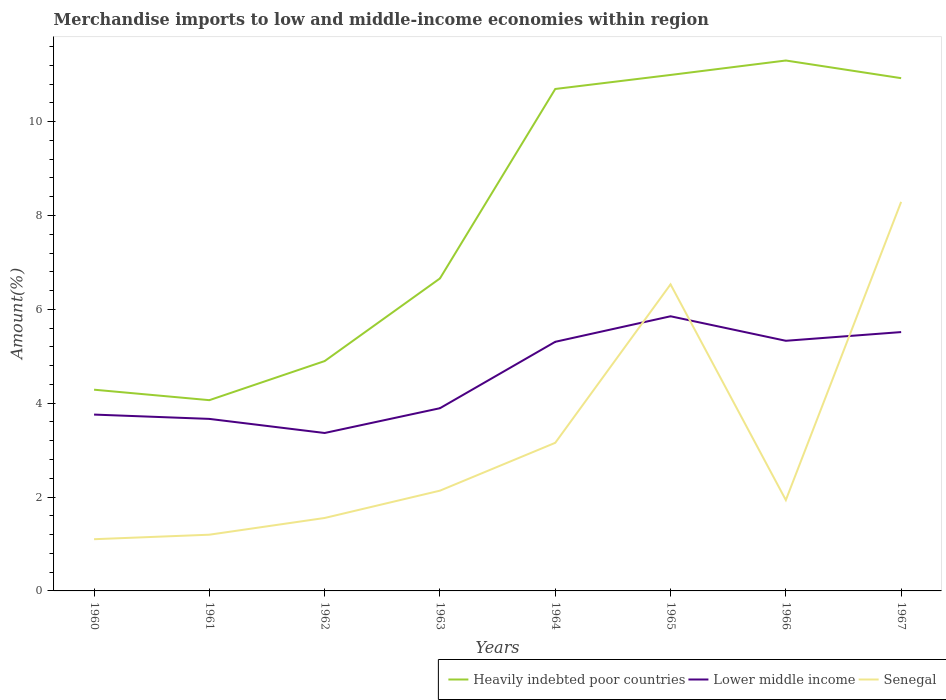How many different coloured lines are there?
Your answer should be very brief. 3. Is the number of lines equal to the number of legend labels?
Your response must be concise. Yes. Across all years, what is the maximum percentage of amount earned from merchandise imports in Heavily indebted poor countries?
Ensure brevity in your answer.  4.06. In which year was the percentage of amount earned from merchandise imports in Heavily indebted poor countries maximum?
Provide a short and direct response. 1961. What is the total percentage of amount earned from merchandise imports in Lower middle income in the graph?
Your answer should be compact. -1.94. What is the difference between the highest and the second highest percentage of amount earned from merchandise imports in Heavily indebted poor countries?
Your response must be concise. 7.24. Is the percentage of amount earned from merchandise imports in Lower middle income strictly greater than the percentage of amount earned from merchandise imports in Senegal over the years?
Offer a very short reply. No. How many lines are there?
Your response must be concise. 3. How many years are there in the graph?
Provide a succinct answer. 8. Does the graph contain grids?
Ensure brevity in your answer.  No. How are the legend labels stacked?
Make the answer very short. Horizontal. What is the title of the graph?
Your answer should be very brief. Merchandise imports to low and middle-income economies within region. What is the label or title of the X-axis?
Your answer should be very brief. Years. What is the label or title of the Y-axis?
Offer a very short reply. Amount(%). What is the Amount(%) in Heavily indebted poor countries in 1960?
Provide a short and direct response. 4.29. What is the Amount(%) in Lower middle income in 1960?
Your response must be concise. 3.76. What is the Amount(%) in Senegal in 1960?
Offer a very short reply. 1.1. What is the Amount(%) in Heavily indebted poor countries in 1961?
Offer a very short reply. 4.06. What is the Amount(%) of Lower middle income in 1961?
Offer a very short reply. 3.67. What is the Amount(%) of Senegal in 1961?
Your response must be concise. 1.2. What is the Amount(%) in Heavily indebted poor countries in 1962?
Give a very brief answer. 4.9. What is the Amount(%) of Lower middle income in 1962?
Your response must be concise. 3.37. What is the Amount(%) of Senegal in 1962?
Keep it short and to the point. 1.55. What is the Amount(%) in Heavily indebted poor countries in 1963?
Ensure brevity in your answer.  6.66. What is the Amount(%) of Lower middle income in 1963?
Provide a succinct answer. 3.89. What is the Amount(%) of Senegal in 1963?
Provide a succinct answer. 2.14. What is the Amount(%) in Heavily indebted poor countries in 1964?
Provide a short and direct response. 10.7. What is the Amount(%) in Lower middle income in 1964?
Ensure brevity in your answer.  5.31. What is the Amount(%) in Senegal in 1964?
Offer a very short reply. 3.16. What is the Amount(%) in Heavily indebted poor countries in 1965?
Make the answer very short. 10.99. What is the Amount(%) of Lower middle income in 1965?
Provide a succinct answer. 5.85. What is the Amount(%) of Senegal in 1965?
Ensure brevity in your answer.  6.53. What is the Amount(%) of Heavily indebted poor countries in 1966?
Give a very brief answer. 11.3. What is the Amount(%) of Lower middle income in 1966?
Make the answer very short. 5.33. What is the Amount(%) in Senegal in 1966?
Your answer should be compact. 1.94. What is the Amount(%) in Heavily indebted poor countries in 1967?
Provide a succinct answer. 10.93. What is the Amount(%) in Lower middle income in 1967?
Provide a short and direct response. 5.52. What is the Amount(%) of Senegal in 1967?
Provide a short and direct response. 8.29. Across all years, what is the maximum Amount(%) in Heavily indebted poor countries?
Ensure brevity in your answer.  11.3. Across all years, what is the maximum Amount(%) in Lower middle income?
Offer a terse response. 5.85. Across all years, what is the maximum Amount(%) of Senegal?
Offer a terse response. 8.29. Across all years, what is the minimum Amount(%) in Heavily indebted poor countries?
Your response must be concise. 4.06. Across all years, what is the minimum Amount(%) in Lower middle income?
Offer a terse response. 3.37. Across all years, what is the minimum Amount(%) of Senegal?
Your answer should be compact. 1.1. What is the total Amount(%) in Heavily indebted poor countries in the graph?
Offer a terse response. 63.83. What is the total Amount(%) of Lower middle income in the graph?
Your answer should be compact. 36.69. What is the total Amount(%) of Senegal in the graph?
Your response must be concise. 25.9. What is the difference between the Amount(%) of Heavily indebted poor countries in 1960 and that in 1961?
Your answer should be very brief. 0.22. What is the difference between the Amount(%) in Lower middle income in 1960 and that in 1961?
Offer a very short reply. 0.09. What is the difference between the Amount(%) of Senegal in 1960 and that in 1961?
Provide a short and direct response. -0.1. What is the difference between the Amount(%) of Heavily indebted poor countries in 1960 and that in 1962?
Offer a very short reply. -0.61. What is the difference between the Amount(%) in Lower middle income in 1960 and that in 1962?
Keep it short and to the point. 0.39. What is the difference between the Amount(%) of Senegal in 1960 and that in 1962?
Ensure brevity in your answer.  -0.45. What is the difference between the Amount(%) in Heavily indebted poor countries in 1960 and that in 1963?
Offer a terse response. -2.37. What is the difference between the Amount(%) of Lower middle income in 1960 and that in 1963?
Your answer should be very brief. -0.14. What is the difference between the Amount(%) in Senegal in 1960 and that in 1963?
Keep it short and to the point. -1.03. What is the difference between the Amount(%) in Heavily indebted poor countries in 1960 and that in 1964?
Make the answer very short. -6.41. What is the difference between the Amount(%) in Lower middle income in 1960 and that in 1964?
Provide a short and direct response. -1.55. What is the difference between the Amount(%) of Senegal in 1960 and that in 1964?
Offer a very short reply. -2.05. What is the difference between the Amount(%) in Heavily indebted poor countries in 1960 and that in 1965?
Your answer should be compact. -6.71. What is the difference between the Amount(%) of Lower middle income in 1960 and that in 1965?
Make the answer very short. -2.09. What is the difference between the Amount(%) in Senegal in 1960 and that in 1965?
Your answer should be compact. -5.43. What is the difference between the Amount(%) in Heavily indebted poor countries in 1960 and that in 1966?
Your answer should be compact. -7.01. What is the difference between the Amount(%) of Lower middle income in 1960 and that in 1966?
Keep it short and to the point. -1.57. What is the difference between the Amount(%) of Senegal in 1960 and that in 1966?
Your response must be concise. -0.83. What is the difference between the Amount(%) of Heavily indebted poor countries in 1960 and that in 1967?
Provide a short and direct response. -6.64. What is the difference between the Amount(%) in Lower middle income in 1960 and that in 1967?
Your answer should be very brief. -1.76. What is the difference between the Amount(%) of Senegal in 1960 and that in 1967?
Provide a short and direct response. -7.19. What is the difference between the Amount(%) of Heavily indebted poor countries in 1961 and that in 1962?
Keep it short and to the point. -0.83. What is the difference between the Amount(%) in Lower middle income in 1961 and that in 1962?
Offer a very short reply. 0.3. What is the difference between the Amount(%) in Senegal in 1961 and that in 1962?
Your response must be concise. -0.36. What is the difference between the Amount(%) in Heavily indebted poor countries in 1961 and that in 1963?
Provide a short and direct response. -2.59. What is the difference between the Amount(%) of Lower middle income in 1961 and that in 1963?
Offer a terse response. -0.23. What is the difference between the Amount(%) in Senegal in 1961 and that in 1963?
Your answer should be compact. -0.94. What is the difference between the Amount(%) in Heavily indebted poor countries in 1961 and that in 1964?
Keep it short and to the point. -6.63. What is the difference between the Amount(%) in Lower middle income in 1961 and that in 1964?
Ensure brevity in your answer.  -1.64. What is the difference between the Amount(%) in Senegal in 1961 and that in 1964?
Ensure brevity in your answer.  -1.96. What is the difference between the Amount(%) of Heavily indebted poor countries in 1961 and that in 1965?
Make the answer very short. -6.93. What is the difference between the Amount(%) of Lower middle income in 1961 and that in 1965?
Your answer should be compact. -2.19. What is the difference between the Amount(%) of Senegal in 1961 and that in 1965?
Your answer should be very brief. -5.33. What is the difference between the Amount(%) of Heavily indebted poor countries in 1961 and that in 1966?
Your answer should be compact. -7.24. What is the difference between the Amount(%) in Lower middle income in 1961 and that in 1966?
Make the answer very short. -1.66. What is the difference between the Amount(%) of Senegal in 1961 and that in 1966?
Give a very brief answer. -0.74. What is the difference between the Amount(%) of Heavily indebted poor countries in 1961 and that in 1967?
Your answer should be very brief. -6.86. What is the difference between the Amount(%) of Lower middle income in 1961 and that in 1967?
Provide a short and direct response. -1.85. What is the difference between the Amount(%) of Senegal in 1961 and that in 1967?
Offer a very short reply. -7.09. What is the difference between the Amount(%) of Heavily indebted poor countries in 1962 and that in 1963?
Ensure brevity in your answer.  -1.76. What is the difference between the Amount(%) of Lower middle income in 1962 and that in 1963?
Ensure brevity in your answer.  -0.53. What is the difference between the Amount(%) in Senegal in 1962 and that in 1963?
Give a very brief answer. -0.58. What is the difference between the Amount(%) of Heavily indebted poor countries in 1962 and that in 1964?
Your answer should be very brief. -5.8. What is the difference between the Amount(%) of Lower middle income in 1962 and that in 1964?
Your response must be concise. -1.94. What is the difference between the Amount(%) in Senegal in 1962 and that in 1964?
Provide a succinct answer. -1.6. What is the difference between the Amount(%) of Heavily indebted poor countries in 1962 and that in 1965?
Offer a very short reply. -6.1. What is the difference between the Amount(%) in Lower middle income in 1962 and that in 1965?
Give a very brief answer. -2.49. What is the difference between the Amount(%) in Senegal in 1962 and that in 1965?
Provide a short and direct response. -4.98. What is the difference between the Amount(%) of Heavily indebted poor countries in 1962 and that in 1966?
Keep it short and to the point. -6.4. What is the difference between the Amount(%) in Lower middle income in 1962 and that in 1966?
Your answer should be compact. -1.96. What is the difference between the Amount(%) of Senegal in 1962 and that in 1966?
Give a very brief answer. -0.38. What is the difference between the Amount(%) in Heavily indebted poor countries in 1962 and that in 1967?
Ensure brevity in your answer.  -6.03. What is the difference between the Amount(%) in Lower middle income in 1962 and that in 1967?
Your answer should be very brief. -2.15. What is the difference between the Amount(%) in Senegal in 1962 and that in 1967?
Provide a succinct answer. -6.74. What is the difference between the Amount(%) in Heavily indebted poor countries in 1963 and that in 1964?
Ensure brevity in your answer.  -4.04. What is the difference between the Amount(%) in Lower middle income in 1963 and that in 1964?
Your answer should be compact. -1.41. What is the difference between the Amount(%) in Senegal in 1963 and that in 1964?
Keep it short and to the point. -1.02. What is the difference between the Amount(%) of Heavily indebted poor countries in 1963 and that in 1965?
Your answer should be compact. -4.34. What is the difference between the Amount(%) in Lower middle income in 1963 and that in 1965?
Your response must be concise. -1.96. What is the difference between the Amount(%) of Senegal in 1963 and that in 1965?
Ensure brevity in your answer.  -4.4. What is the difference between the Amount(%) in Heavily indebted poor countries in 1963 and that in 1966?
Keep it short and to the point. -4.64. What is the difference between the Amount(%) in Lower middle income in 1963 and that in 1966?
Provide a succinct answer. -1.44. What is the difference between the Amount(%) in Senegal in 1963 and that in 1966?
Ensure brevity in your answer.  0.2. What is the difference between the Amount(%) in Heavily indebted poor countries in 1963 and that in 1967?
Provide a short and direct response. -4.27. What is the difference between the Amount(%) of Lower middle income in 1963 and that in 1967?
Your answer should be very brief. -1.62. What is the difference between the Amount(%) in Senegal in 1963 and that in 1967?
Ensure brevity in your answer.  -6.15. What is the difference between the Amount(%) in Heavily indebted poor countries in 1964 and that in 1965?
Offer a terse response. -0.3. What is the difference between the Amount(%) of Lower middle income in 1964 and that in 1965?
Provide a short and direct response. -0.54. What is the difference between the Amount(%) of Senegal in 1964 and that in 1965?
Ensure brevity in your answer.  -3.38. What is the difference between the Amount(%) of Heavily indebted poor countries in 1964 and that in 1966?
Your answer should be compact. -0.61. What is the difference between the Amount(%) of Lower middle income in 1964 and that in 1966?
Make the answer very short. -0.02. What is the difference between the Amount(%) of Senegal in 1964 and that in 1966?
Offer a terse response. 1.22. What is the difference between the Amount(%) in Heavily indebted poor countries in 1964 and that in 1967?
Keep it short and to the point. -0.23. What is the difference between the Amount(%) of Lower middle income in 1964 and that in 1967?
Make the answer very short. -0.21. What is the difference between the Amount(%) of Senegal in 1964 and that in 1967?
Give a very brief answer. -5.13. What is the difference between the Amount(%) of Heavily indebted poor countries in 1965 and that in 1966?
Keep it short and to the point. -0.31. What is the difference between the Amount(%) in Lower middle income in 1965 and that in 1966?
Ensure brevity in your answer.  0.52. What is the difference between the Amount(%) of Senegal in 1965 and that in 1966?
Provide a short and direct response. 4.6. What is the difference between the Amount(%) of Heavily indebted poor countries in 1965 and that in 1967?
Give a very brief answer. 0.07. What is the difference between the Amount(%) of Lower middle income in 1965 and that in 1967?
Make the answer very short. 0.34. What is the difference between the Amount(%) in Senegal in 1965 and that in 1967?
Give a very brief answer. -1.76. What is the difference between the Amount(%) of Heavily indebted poor countries in 1966 and that in 1967?
Offer a very short reply. 0.38. What is the difference between the Amount(%) in Lower middle income in 1966 and that in 1967?
Offer a very short reply. -0.19. What is the difference between the Amount(%) of Senegal in 1966 and that in 1967?
Offer a very short reply. -6.35. What is the difference between the Amount(%) in Heavily indebted poor countries in 1960 and the Amount(%) in Lower middle income in 1961?
Your answer should be very brief. 0.62. What is the difference between the Amount(%) of Heavily indebted poor countries in 1960 and the Amount(%) of Senegal in 1961?
Offer a very short reply. 3.09. What is the difference between the Amount(%) of Lower middle income in 1960 and the Amount(%) of Senegal in 1961?
Your answer should be very brief. 2.56. What is the difference between the Amount(%) of Heavily indebted poor countries in 1960 and the Amount(%) of Lower middle income in 1962?
Your answer should be compact. 0.92. What is the difference between the Amount(%) of Heavily indebted poor countries in 1960 and the Amount(%) of Senegal in 1962?
Your answer should be very brief. 2.73. What is the difference between the Amount(%) of Lower middle income in 1960 and the Amount(%) of Senegal in 1962?
Offer a terse response. 2.2. What is the difference between the Amount(%) of Heavily indebted poor countries in 1960 and the Amount(%) of Lower middle income in 1963?
Provide a succinct answer. 0.39. What is the difference between the Amount(%) in Heavily indebted poor countries in 1960 and the Amount(%) in Senegal in 1963?
Offer a terse response. 2.15. What is the difference between the Amount(%) of Lower middle income in 1960 and the Amount(%) of Senegal in 1963?
Your response must be concise. 1.62. What is the difference between the Amount(%) of Heavily indebted poor countries in 1960 and the Amount(%) of Lower middle income in 1964?
Keep it short and to the point. -1.02. What is the difference between the Amount(%) of Heavily indebted poor countries in 1960 and the Amount(%) of Senegal in 1964?
Offer a very short reply. 1.13. What is the difference between the Amount(%) in Lower middle income in 1960 and the Amount(%) in Senegal in 1964?
Your response must be concise. 0.6. What is the difference between the Amount(%) of Heavily indebted poor countries in 1960 and the Amount(%) of Lower middle income in 1965?
Give a very brief answer. -1.56. What is the difference between the Amount(%) of Heavily indebted poor countries in 1960 and the Amount(%) of Senegal in 1965?
Give a very brief answer. -2.24. What is the difference between the Amount(%) of Lower middle income in 1960 and the Amount(%) of Senegal in 1965?
Provide a short and direct response. -2.77. What is the difference between the Amount(%) in Heavily indebted poor countries in 1960 and the Amount(%) in Lower middle income in 1966?
Your answer should be very brief. -1.04. What is the difference between the Amount(%) of Heavily indebted poor countries in 1960 and the Amount(%) of Senegal in 1966?
Ensure brevity in your answer.  2.35. What is the difference between the Amount(%) of Lower middle income in 1960 and the Amount(%) of Senegal in 1966?
Keep it short and to the point. 1.82. What is the difference between the Amount(%) in Heavily indebted poor countries in 1960 and the Amount(%) in Lower middle income in 1967?
Your answer should be very brief. -1.23. What is the difference between the Amount(%) of Heavily indebted poor countries in 1960 and the Amount(%) of Senegal in 1967?
Offer a terse response. -4. What is the difference between the Amount(%) in Lower middle income in 1960 and the Amount(%) in Senegal in 1967?
Your response must be concise. -4.53. What is the difference between the Amount(%) of Heavily indebted poor countries in 1961 and the Amount(%) of Lower middle income in 1962?
Offer a very short reply. 0.7. What is the difference between the Amount(%) in Heavily indebted poor countries in 1961 and the Amount(%) in Senegal in 1962?
Offer a terse response. 2.51. What is the difference between the Amount(%) in Lower middle income in 1961 and the Amount(%) in Senegal in 1962?
Your answer should be compact. 2.11. What is the difference between the Amount(%) in Heavily indebted poor countries in 1961 and the Amount(%) in Lower middle income in 1963?
Ensure brevity in your answer.  0.17. What is the difference between the Amount(%) of Heavily indebted poor countries in 1961 and the Amount(%) of Senegal in 1963?
Make the answer very short. 1.93. What is the difference between the Amount(%) of Lower middle income in 1961 and the Amount(%) of Senegal in 1963?
Provide a short and direct response. 1.53. What is the difference between the Amount(%) in Heavily indebted poor countries in 1961 and the Amount(%) in Lower middle income in 1964?
Provide a short and direct response. -1.24. What is the difference between the Amount(%) in Heavily indebted poor countries in 1961 and the Amount(%) in Senegal in 1964?
Make the answer very short. 0.91. What is the difference between the Amount(%) of Lower middle income in 1961 and the Amount(%) of Senegal in 1964?
Your answer should be compact. 0.51. What is the difference between the Amount(%) of Heavily indebted poor countries in 1961 and the Amount(%) of Lower middle income in 1965?
Ensure brevity in your answer.  -1.79. What is the difference between the Amount(%) of Heavily indebted poor countries in 1961 and the Amount(%) of Senegal in 1965?
Your answer should be compact. -2.47. What is the difference between the Amount(%) of Lower middle income in 1961 and the Amount(%) of Senegal in 1965?
Give a very brief answer. -2.87. What is the difference between the Amount(%) of Heavily indebted poor countries in 1961 and the Amount(%) of Lower middle income in 1966?
Ensure brevity in your answer.  -1.27. What is the difference between the Amount(%) of Heavily indebted poor countries in 1961 and the Amount(%) of Senegal in 1966?
Provide a succinct answer. 2.13. What is the difference between the Amount(%) of Lower middle income in 1961 and the Amount(%) of Senegal in 1966?
Your response must be concise. 1.73. What is the difference between the Amount(%) of Heavily indebted poor countries in 1961 and the Amount(%) of Lower middle income in 1967?
Make the answer very short. -1.45. What is the difference between the Amount(%) of Heavily indebted poor countries in 1961 and the Amount(%) of Senegal in 1967?
Provide a short and direct response. -4.23. What is the difference between the Amount(%) of Lower middle income in 1961 and the Amount(%) of Senegal in 1967?
Give a very brief answer. -4.62. What is the difference between the Amount(%) of Heavily indebted poor countries in 1962 and the Amount(%) of Lower middle income in 1963?
Ensure brevity in your answer.  1. What is the difference between the Amount(%) in Heavily indebted poor countries in 1962 and the Amount(%) in Senegal in 1963?
Offer a terse response. 2.76. What is the difference between the Amount(%) in Lower middle income in 1962 and the Amount(%) in Senegal in 1963?
Offer a very short reply. 1.23. What is the difference between the Amount(%) in Heavily indebted poor countries in 1962 and the Amount(%) in Lower middle income in 1964?
Your answer should be very brief. -0.41. What is the difference between the Amount(%) of Heavily indebted poor countries in 1962 and the Amount(%) of Senegal in 1964?
Make the answer very short. 1.74. What is the difference between the Amount(%) of Lower middle income in 1962 and the Amount(%) of Senegal in 1964?
Ensure brevity in your answer.  0.21. What is the difference between the Amount(%) of Heavily indebted poor countries in 1962 and the Amount(%) of Lower middle income in 1965?
Make the answer very short. -0.95. What is the difference between the Amount(%) in Heavily indebted poor countries in 1962 and the Amount(%) in Senegal in 1965?
Provide a succinct answer. -1.63. What is the difference between the Amount(%) of Lower middle income in 1962 and the Amount(%) of Senegal in 1965?
Keep it short and to the point. -3.17. What is the difference between the Amount(%) in Heavily indebted poor countries in 1962 and the Amount(%) in Lower middle income in 1966?
Make the answer very short. -0.43. What is the difference between the Amount(%) of Heavily indebted poor countries in 1962 and the Amount(%) of Senegal in 1966?
Give a very brief answer. 2.96. What is the difference between the Amount(%) of Lower middle income in 1962 and the Amount(%) of Senegal in 1966?
Provide a succinct answer. 1.43. What is the difference between the Amount(%) in Heavily indebted poor countries in 1962 and the Amount(%) in Lower middle income in 1967?
Offer a terse response. -0.62. What is the difference between the Amount(%) of Heavily indebted poor countries in 1962 and the Amount(%) of Senegal in 1967?
Ensure brevity in your answer.  -3.39. What is the difference between the Amount(%) in Lower middle income in 1962 and the Amount(%) in Senegal in 1967?
Your response must be concise. -4.92. What is the difference between the Amount(%) in Heavily indebted poor countries in 1963 and the Amount(%) in Lower middle income in 1964?
Ensure brevity in your answer.  1.35. What is the difference between the Amount(%) in Heavily indebted poor countries in 1963 and the Amount(%) in Senegal in 1964?
Offer a terse response. 3.5. What is the difference between the Amount(%) in Lower middle income in 1963 and the Amount(%) in Senegal in 1964?
Offer a terse response. 0.74. What is the difference between the Amount(%) of Heavily indebted poor countries in 1963 and the Amount(%) of Lower middle income in 1965?
Ensure brevity in your answer.  0.81. What is the difference between the Amount(%) of Heavily indebted poor countries in 1963 and the Amount(%) of Senegal in 1965?
Ensure brevity in your answer.  0.13. What is the difference between the Amount(%) in Lower middle income in 1963 and the Amount(%) in Senegal in 1965?
Provide a succinct answer. -2.64. What is the difference between the Amount(%) in Heavily indebted poor countries in 1963 and the Amount(%) in Lower middle income in 1966?
Offer a terse response. 1.33. What is the difference between the Amount(%) in Heavily indebted poor countries in 1963 and the Amount(%) in Senegal in 1966?
Your answer should be very brief. 4.72. What is the difference between the Amount(%) of Lower middle income in 1963 and the Amount(%) of Senegal in 1966?
Ensure brevity in your answer.  1.96. What is the difference between the Amount(%) in Heavily indebted poor countries in 1963 and the Amount(%) in Lower middle income in 1967?
Offer a very short reply. 1.14. What is the difference between the Amount(%) in Heavily indebted poor countries in 1963 and the Amount(%) in Senegal in 1967?
Provide a short and direct response. -1.63. What is the difference between the Amount(%) in Lower middle income in 1963 and the Amount(%) in Senegal in 1967?
Make the answer very short. -4.4. What is the difference between the Amount(%) of Heavily indebted poor countries in 1964 and the Amount(%) of Lower middle income in 1965?
Offer a terse response. 4.84. What is the difference between the Amount(%) in Heavily indebted poor countries in 1964 and the Amount(%) in Senegal in 1965?
Offer a terse response. 4.16. What is the difference between the Amount(%) in Lower middle income in 1964 and the Amount(%) in Senegal in 1965?
Your response must be concise. -1.22. What is the difference between the Amount(%) of Heavily indebted poor countries in 1964 and the Amount(%) of Lower middle income in 1966?
Give a very brief answer. 5.37. What is the difference between the Amount(%) of Heavily indebted poor countries in 1964 and the Amount(%) of Senegal in 1966?
Your response must be concise. 8.76. What is the difference between the Amount(%) of Lower middle income in 1964 and the Amount(%) of Senegal in 1966?
Ensure brevity in your answer.  3.37. What is the difference between the Amount(%) in Heavily indebted poor countries in 1964 and the Amount(%) in Lower middle income in 1967?
Make the answer very short. 5.18. What is the difference between the Amount(%) in Heavily indebted poor countries in 1964 and the Amount(%) in Senegal in 1967?
Provide a succinct answer. 2.41. What is the difference between the Amount(%) of Lower middle income in 1964 and the Amount(%) of Senegal in 1967?
Offer a terse response. -2.98. What is the difference between the Amount(%) in Heavily indebted poor countries in 1965 and the Amount(%) in Lower middle income in 1966?
Your answer should be compact. 5.66. What is the difference between the Amount(%) in Heavily indebted poor countries in 1965 and the Amount(%) in Senegal in 1966?
Ensure brevity in your answer.  9.06. What is the difference between the Amount(%) in Lower middle income in 1965 and the Amount(%) in Senegal in 1966?
Provide a short and direct response. 3.92. What is the difference between the Amount(%) of Heavily indebted poor countries in 1965 and the Amount(%) of Lower middle income in 1967?
Your answer should be compact. 5.48. What is the difference between the Amount(%) of Heavily indebted poor countries in 1965 and the Amount(%) of Senegal in 1967?
Your answer should be compact. 2.7. What is the difference between the Amount(%) in Lower middle income in 1965 and the Amount(%) in Senegal in 1967?
Give a very brief answer. -2.44. What is the difference between the Amount(%) in Heavily indebted poor countries in 1966 and the Amount(%) in Lower middle income in 1967?
Offer a terse response. 5.79. What is the difference between the Amount(%) of Heavily indebted poor countries in 1966 and the Amount(%) of Senegal in 1967?
Keep it short and to the point. 3.01. What is the difference between the Amount(%) in Lower middle income in 1966 and the Amount(%) in Senegal in 1967?
Offer a terse response. -2.96. What is the average Amount(%) in Heavily indebted poor countries per year?
Ensure brevity in your answer.  7.98. What is the average Amount(%) in Lower middle income per year?
Keep it short and to the point. 4.59. What is the average Amount(%) of Senegal per year?
Provide a succinct answer. 3.24. In the year 1960, what is the difference between the Amount(%) of Heavily indebted poor countries and Amount(%) of Lower middle income?
Provide a succinct answer. 0.53. In the year 1960, what is the difference between the Amount(%) in Heavily indebted poor countries and Amount(%) in Senegal?
Provide a succinct answer. 3.19. In the year 1960, what is the difference between the Amount(%) in Lower middle income and Amount(%) in Senegal?
Offer a very short reply. 2.66. In the year 1961, what is the difference between the Amount(%) in Heavily indebted poor countries and Amount(%) in Lower middle income?
Your answer should be very brief. 0.4. In the year 1961, what is the difference between the Amount(%) in Heavily indebted poor countries and Amount(%) in Senegal?
Your response must be concise. 2.87. In the year 1961, what is the difference between the Amount(%) of Lower middle income and Amount(%) of Senegal?
Offer a very short reply. 2.47. In the year 1962, what is the difference between the Amount(%) in Heavily indebted poor countries and Amount(%) in Lower middle income?
Offer a terse response. 1.53. In the year 1962, what is the difference between the Amount(%) in Heavily indebted poor countries and Amount(%) in Senegal?
Keep it short and to the point. 3.34. In the year 1962, what is the difference between the Amount(%) of Lower middle income and Amount(%) of Senegal?
Keep it short and to the point. 1.81. In the year 1963, what is the difference between the Amount(%) of Heavily indebted poor countries and Amount(%) of Lower middle income?
Provide a short and direct response. 2.77. In the year 1963, what is the difference between the Amount(%) of Heavily indebted poor countries and Amount(%) of Senegal?
Your response must be concise. 4.52. In the year 1963, what is the difference between the Amount(%) of Lower middle income and Amount(%) of Senegal?
Provide a succinct answer. 1.76. In the year 1964, what is the difference between the Amount(%) in Heavily indebted poor countries and Amount(%) in Lower middle income?
Make the answer very short. 5.39. In the year 1964, what is the difference between the Amount(%) of Heavily indebted poor countries and Amount(%) of Senegal?
Offer a very short reply. 7.54. In the year 1964, what is the difference between the Amount(%) of Lower middle income and Amount(%) of Senegal?
Give a very brief answer. 2.15. In the year 1965, what is the difference between the Amount(%) of Heavily indebted poor countries and Amount(%) of Lower middle income?
Your answer should be very brief. 5.14. In the year 1965, what is the difference between the Amount(%) in Heavily indebted poor countries and Amount(%) in Senegal?
Offer a terse response. 4.46. In the year 1965, what is the difference between the Amount(%) of Lower middle income and Amount(%) of Senegal?
Make the answer very short. -0.68. In the year 1966, what is the difference between the Amount(%) in Heavily indebted poor countries and Amount(%) in Lower middle income?
Offer a very short reply. 5.97. In the year 1966, what is the difference between the Amount(%) in Heavily indebted poor countries and Amount(%) in Senegal?
Give a very brief answer. 9.37. In the year 1966, what is the difference between the Amount(%) in Lower middle income and Amount(%) in Senegal?
Provide a succinct answer. 3.39. In the year 1967, what is the difference between the Amount(%) in Heavily indebted poor countries and Amount(%) in Lower middle income?
Your answer should be compact. 5.41. In the year 1967, what is the difference between the Amount(%) in Heavily indebted poor countries and Amount(%) in Senegal?
Your response must be concise. 2.64. In the year 1967, what is the difference between the Amount(%) of Lower middle income and Amount(%) of Senegal?
Keep it short and to the point. -2.77. What is the ratio of the Amount(%) of Heavily indebted poor countries in 1960 to that in 1961?
Your response must be concise. 1.05. What is the ratio of the Amount(%) in Lower middle income in 1960 to that in 1961?
Provide a short and direct response. 1.03. What is the ratio of the Amount(%) in Heavily indebted poor countries in 1960 to that in 1962?
Your answer should be very brief. 0.88. What is the ratio of the Amount(%) of Lower middle income in 1960 to that in 1962?
Your answer should be very brief. 1.12. What is the ratio of the Amount(%) of Senegal in 1960 to that in 1962?
Keep it short and to the point. 0.71. What is the ratio of the Amount(%) of Heavily indebted poor countries in 1960 to that in 1963?
Give a very brief answer. 0.64. What is the ratio of the Amount(%) of Lower middle income in 1960 to that in 1963?
Provide a succinct answer. 0.97. What is the ratio of the Amount(%) in Senegal in 1960 to that in 1963?
Your answer should be compact. 0.52. What is the ratio of the Amount(%) of Heavily indebted poor countries in 1960 to that in 1964?
Provide a short and direct response. 0.4. What is the ratio of the Amount(%) in Lower middle income in 1960 to that in 1964?
Give a very brief answer. 0.71. What is the ratio of the Amount(%) in Senegal in 1960 to that in 1964?
Ensure brevity in your answer.  0.35. What is the ratio of the Amount(%) in Heavily indebted poor countries in 1960 to that in 1965?
Make the answer very short. 0.39. What is the ratio of the Amount(%) of Lower middle income in 1960 to that in 1965?
Make the answer very short. 0.64. What is the ratio of the Amount(%) in Senegal in 1960 to that in 1965?
Offer a terse response. 0.17. What is the ratio of the Amount(%) in Heavily indebted poor countries in 1960 to that in 1966?
Offer a very short reply. 0.38. What is the ratio of the Amount(%) in Lower middle income in 1960 to that in 1966?
Your answer should be compact. 0.7. What is the ratio of the Amount(%) of Senegal in 1960 to that in 1966?
Provide a short and direct response. 0.57. What is the ratio of the Amount(%) of Heavily indebted poor countries in 1960 to that in 1967?
Make the answer very short. 0.39. What is the ratio of the Amount(%) of Lower middle income in 1960 to that in 1967?
Provide a succinct answer. 0.68. What is the ratio of the Amount(%) of Senegal in 1960 to that in 1967?
Offer a terse response. 0.13. What is the ratio of the Amount(%) in Heavily indebted poor countries in 1961 to that in 1962?
Offer a very short reply. 0.83. What is the ratio of the Amount(%) in Lower middle income in 1961 to that in 1962?
Your answer should be compact. 1.09. What is the ratio of the Amount(%) of Senegal in 1961 to that in 1962?
Your answer should be compact. 0.77. What is the ratio of the Amount(%) of Heavily indebted poor countries in 1961 to that in 1963?
Provide a succinct answer. 0.61. What is the ratio of the Amount(%) of Lower middle income in 1961 to that in 1963?
Provide a short and direct response. 0.94. What is the ratio of the Amount(%) in Senegal in 1961 to that in 1963?
Keep it short and to the point. 0.56. What is the ratio of the Amount(%) of Heavily indebted poor countries in 1961 to that in 1964?
Your answer should be very brief. 0.38. What is the ratio of the Amount(%) in Lower middle income in 1961 to that in 1964?
Provide a short and direct response. 0.69. What is the ratio of the Amount(%) in Senegal in 1961 to that in 1964?
Ensure brevity in your answer.  0.38. What is the ratio of the Amount(%) of Heavily indebted poor countries in 1961 to that in 1965?
Ensure brevity in your answer.  0.37. What is the ratio of the Amount(%) of Lower middle income in 1961 to that in 1965?
Provide a succinct answer. 0.63. What is the ratio of the Amount(%) of Senegal in 1961 to that in 1965?
Make the answer very short. 0.18. What is the ratio of the Amount(%) of Heavily indebted poor countries in 1961 to that in 1966?
Provide a short and direct response. 0.36. What is the ratio of the Amount(%) of Lower middle income in 1961 to that in 1966?
Provide a short and direct response. 0.69. What is the ratio of the Amount(%) in Senegal in 1961 to that in 1966?
Make the answer very short. 0.62. What is the ratio of the Amount(%) of Heavily indebted poor countries in 1961 to that in 1967?
Keep it short and to the point. 0.37. What is the ratio of the Amount(%) of Lower middle income in 1961 to that in 1967?
Make the answer very short. 0.66. What is the ratio of the Amount(%) of Senegal in 1961 to that in 1967?
Keep it short and to the point. 0.14. What is the ratio of the Amount(%) of Heavily indebted poor countries in 1962 to that in 1963?
Make the answer very short. 0.74. What is the ratio of the Amount(%) in Lower middle income in 1962 to that in 1963?
Give a very brief answer. 0.86. What is the ratio of the Amount(%) in Senegal in 1962 to that in 1963?
Your response must be concise. 0.73. What is the ratio of the Amount(%) in Heavily indebted poor countries in 1962 to that in 1964?
Your answer should be very brief. 0.46. What is the ratio of the Amount(%) of Lower middle income in 1962 to that in 1964?
Provide a succinct answer. 0.63. What is the ratio of the Amount(%) of Senegal in 1962 to that in 1964?
Your answer should be very brief. 0.49. What is the ratio of the Amount(%) in Heavily indebted poor countries in 1962 to that in 1965?
Ensure brevity in your answer.  0.45. What is the ratio of the Amount(%) of Lower middle income in 1962 to that in 1965?
Your response must be concise. 0.57. What is the ratio of the Amount(%) in Senegal in 1962 to that in 1965?
Your answer should be very brief. 0.24. What is the ratio of the Amount(%) in Heavily indebted poor countries in 1962 to that in 1966?
Offer a terse response. 0.43. What is the ratio of the Amount(%) of Lower middle income in 1962 to that in 1966?
Your response must be concise. 0.63. What is the ratio of the Amount(%) of Senegal in 1962 to that in 1966?
Ensure brevity in your answer.  0.8. What is the ratio of the Amount(%) in Heavily indebted poor countries in 1962 to that in 1967?
Your answer should be very brief. 0.45. What is the ratio of the Amount(%) of Lower middle income in 1962 to that in 1967?
Offer a terse response. 0.61. What is the ratio of the Amount(%) of Senegal in 1962 to that in 1967?
Give a very brief answer. 0.19. What is the ratio of the Amount(%) in Heavily indebted poor countries in 1963 to that in 1964?
Keep it short and to the point. 0.62. What is the ratio of the Amount(%) in Lower middle income in 1963 to that in 1964?
Provide a succinct answer. 0.73. What is the ratio of the Amount(%) of Senegal in 1963 to that in 1964?
Keep it short and to the point. 0.68. What is the ratio of the Amount(%) of Heavily indebted poor countries in 1963 to that in 1965?
Your answer should be very brief. 0.61. What is the ratio of the Amount(%) in Lower middle income in 1963 to that in 1965?
Offer a very short reply. 0.67. What is the ratio of the Amount(%) of Senegal in 1963 to that in 1965?
Your answer should be compact. 0.33. What is the ratio of the Amount(%) of Heavily indebted poor countries in 1963 to that in 1966?
Your answer should be compact. 0.59. What is the ratio of the Amount(%) in Lower middle income in 1963 to that in 1966?
Provide a succinct answer. 0.73. What is the ratio of the Amount(%) in Senegal in 1963 to that in 1966?
Give a very brief answer. 1.1. What is the ratio of the Amount(%) in Heavily indebted poor countries in 1963 to that in 1967?
Provide a succinct answer. 0.61. What is the ratio of the Amount(%) of Lower middle income in 1963 to that in 1967?
Your answer should be compact. 0.71. What is the ratio of the Amount(%) in Senegal in 1963 to that in 1967?
Your answer should be very brief. 0.26. What is the ratio of the Amount(%) of Heavily indebted poor countries in 1964 to that in 1965?
Offer a terse response. 0.97. What is the ratio of the Amount(%) of Lower middle income in 1964 to that in 1965?
Offer a very short reply. 0.91. What is the ratio of the Amount(%) of Senegal in 1964 to that in 1965?
Your answer should be compact. 0.48. What is the ratio of the Amount(%) of Heavily indebted poor countries in 1964 to that in 1966?
Your response must be concise. 0.95. What is the ratio of the Amount(%) of Senegal in 1964 to that in 1966?
Offer a terse response. 1.63. What is the ratio of the Amount(%) of Heavily indebted poor countries in 1964 to that in 1967?
Provide a short and direct response. 0.98. What is the ratio of the Amount(%) in Lower middle income in 1964 to that in 1967?
Ensure brevity in your answer.  0.96. What is the ratio of the Amount(%) in Senegal in 1964 to that in 1967?
Provide a short and direct response. 0.38. What is the ratio of the Amount(%) in Heavily indebted poor countries in 1965 to that in 1966?
Your answer should be very brief. 0.97. What is the ratio of the Amount(%) of Lower middle income in 1965 to that in 1966?
Keep it short and to the point. 1.1. What is the ratio of the Amount(%) in Senegal in 1965 to that in 1966?
Your answer should be compact. 3.38. What is the ratio of the Amount(%) of Heavily indebted poor countries in 1965 to that in 1967?
Provide a short and direct response. 1.01. What is the ratio of the Amount(%) in Lower middle income in 1965 to that in 1967?
Make the answer very short. 1.06. What is the ratio of the Amount(%) of Senegal in 1965 to that in 1967?
Provide a short and direct response. 0.79. What is the ratio of the Amount(%) of Heavily indebted poor countries in 1966 to that in 1967?
Provide a short and direct response. 1.03. What is the ratio of the Amount(%) of Lower middle income in 1966 to that in 1967?
Give a very brief answer. 0.97. What is the ratio of the Amount(%) in Senegal in 1966 to that in 1967?
Offer a very short reply. 0.23. What is the difference between the highest and the second highest Amount(%) of Heavily indebted poor countries?
Give a very brief answer. 0.31. What is the difference between the highest and the second highest Amount(%) in Lower middle income?
Your answer should be compact. 0.34. What is the difference between the highest and the second highest Amount(%) in Senegal?
Offer a terse response. 1.76. What is the difference between the highest and the lowest Amount(%) in Heavily indebted poor countries?
Your response must be concise. 7.24. What is the difference between the highest and the lowest Amount(%) in Lower middle income?
Your answer should be very brief. 2.49. What is the difference between the highest and the lowest Amount(%) in Senegal?
Your answer should be compact. 7.19. 